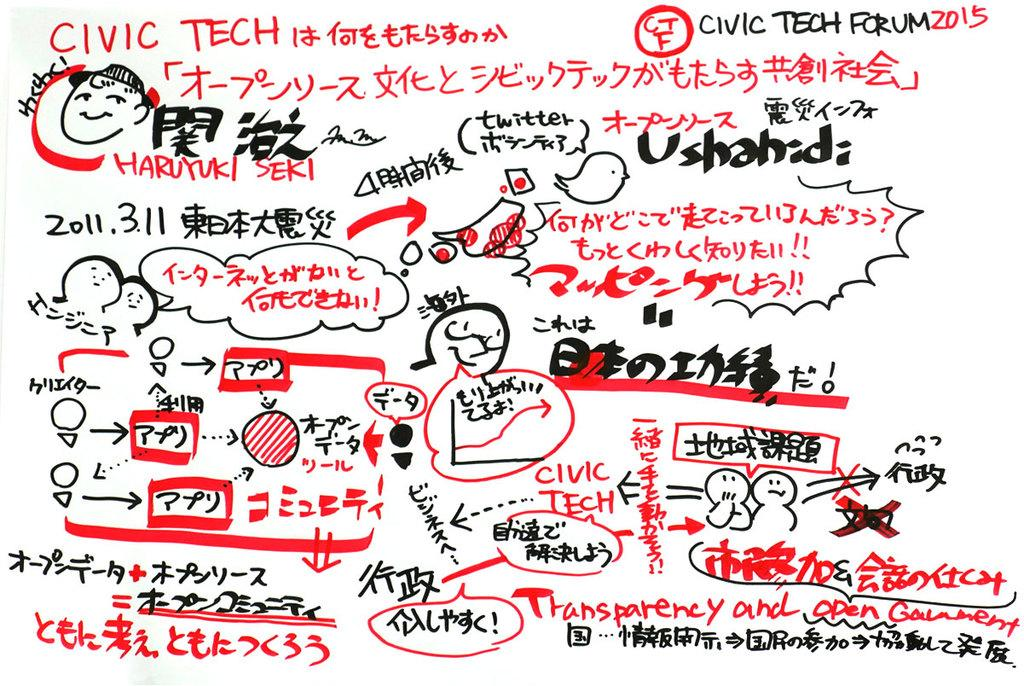What can be found in the image alongside the cartoon drawings? There is some text in the image alongside the cartoon drawings. Can you describe the cartoon drawings in the image? Unfortunately, without more specific information about the cartoon drawings, we cannot provide a detailed description. What color is the vein in the image? There is no vein present in the image. What type of doll is shown in the image? There is no doll present in the image. 